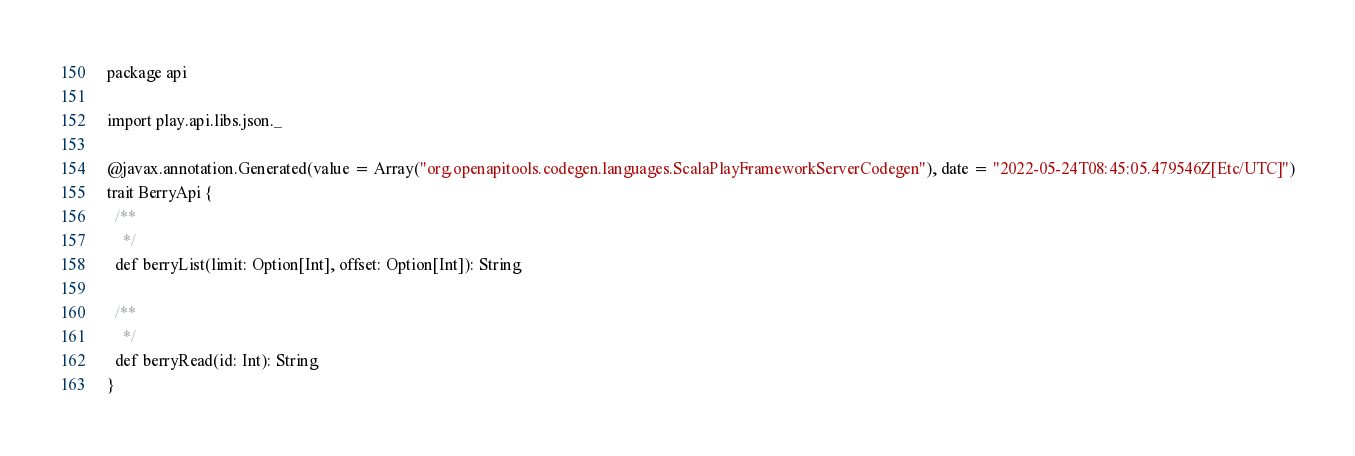Convert code to text. <code><loc_0><loc_0><loc_500><loc_500><_Scala_>package api

import play.api.libs.json._

@javax.annotation.Generated(value = Array("org.openapitools.codegen.languages.ScalaPlayFrameworkServerCodegen"), date = "2022-05-24T08:45:05.479546Z[Etc/UTC]")
trait BerryApi {
  /**
    */
  def berryList(limit: Option[Int], offset: Option[Int]): String

  /**
    */
  def berryRead(id: Int): String
}
</code> 